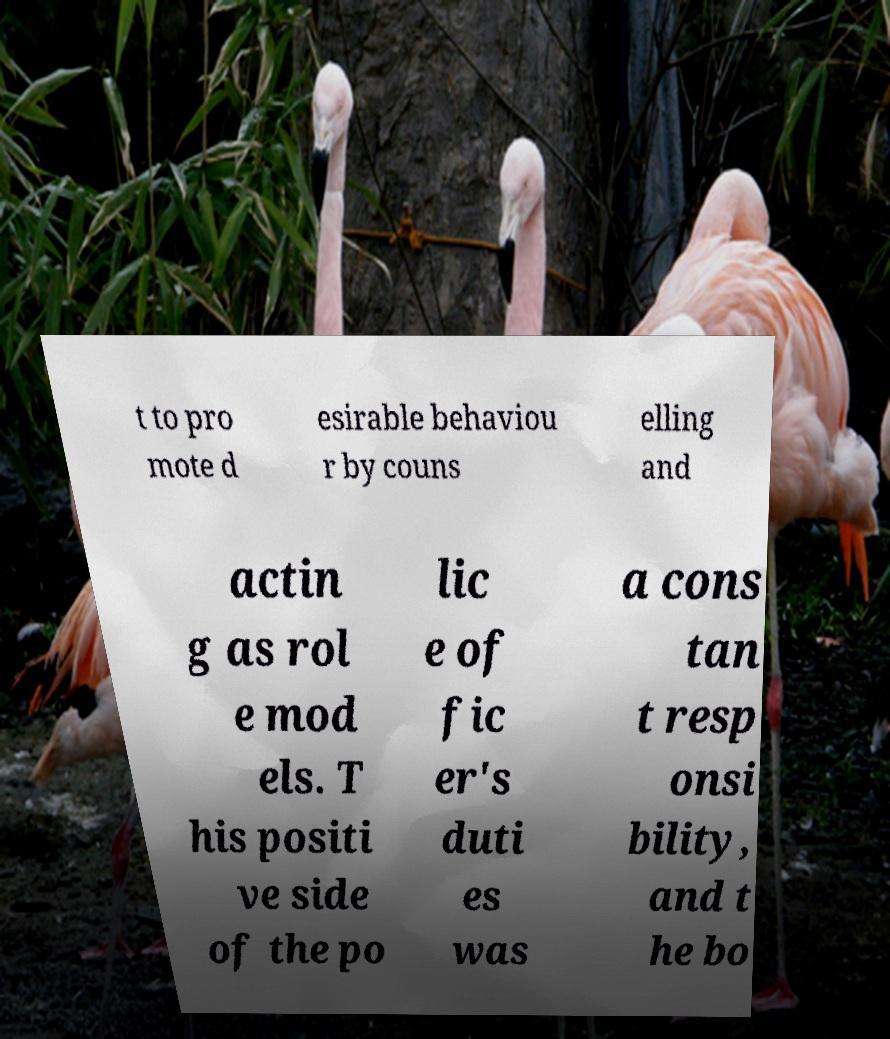Could you extract and type out the text from this image? t to pro mote d esirable behaviou r by couns elling and actin g as rol e mod els. T his positi ve side of the po lic e of fic er's duti es was a cons tan t resp onsi bility, and t he bo 